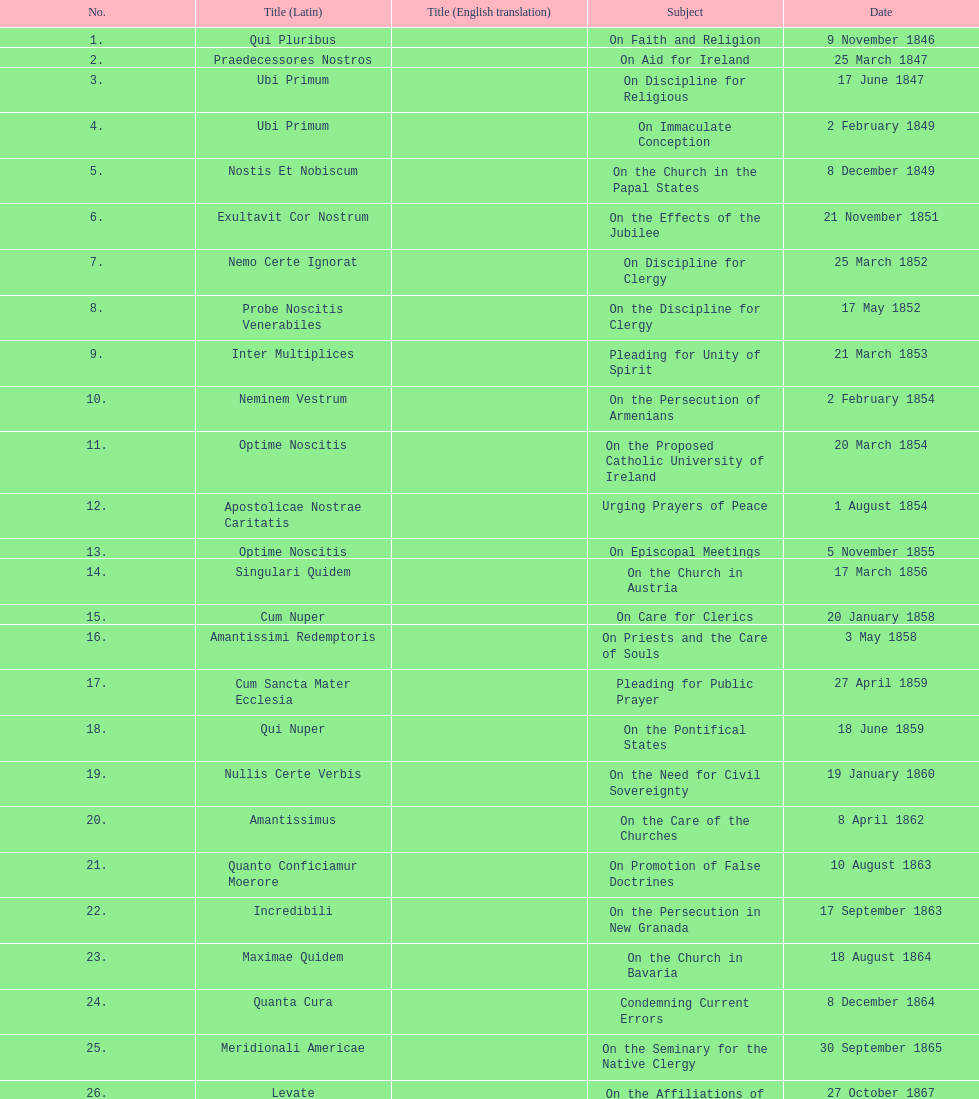Total number of encyclicals on churches . 11. 